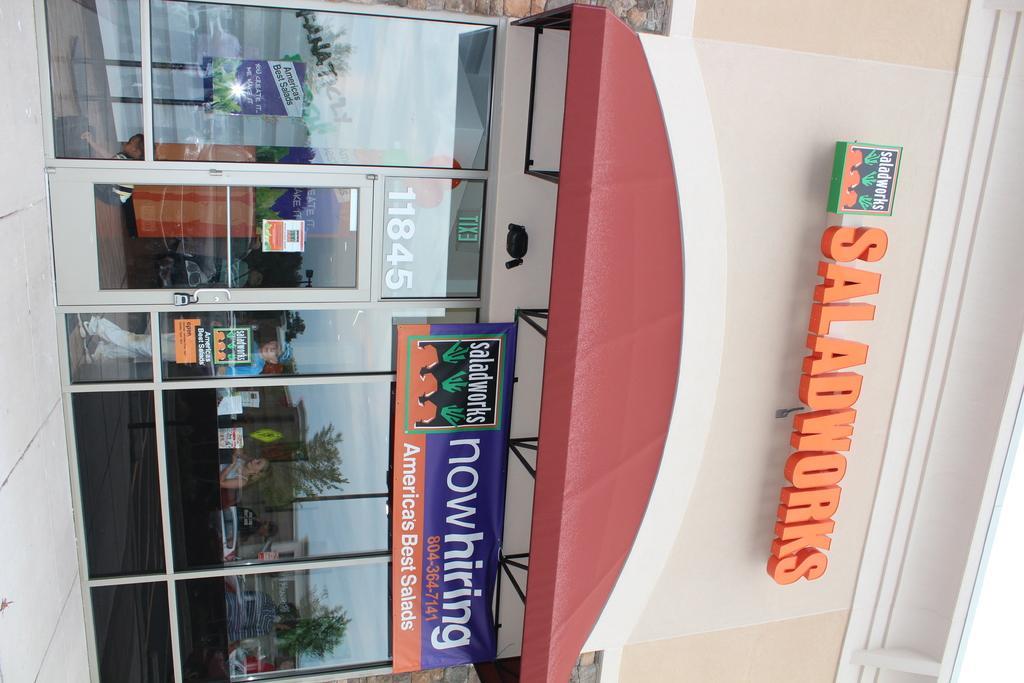Describe this image in one or two sentences. There is a building which has glass walls and a door. It has a board and on the top 'saladworks' is written in orange color. 